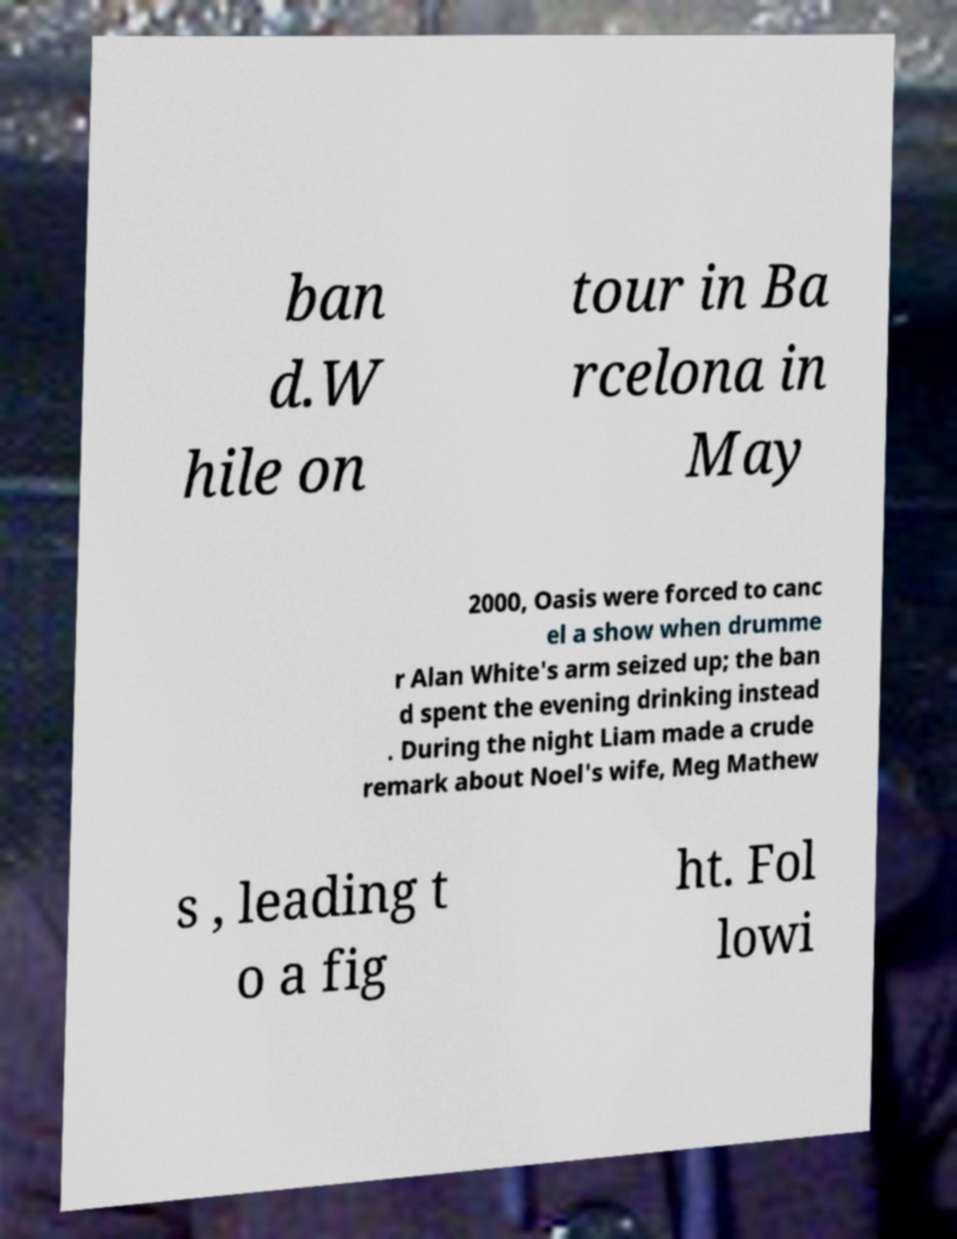Please read and relay the text visible in this image. What does it say? ban d.W hile on tour in Ba rcelona in May 2000, Oasis were forced to canc el a show when drumme r Alan White's arm seized up; the ban d spent the evening drinking instead . During the night Liam made a crude remark about Noel's wife, Meg Mathew s , leading t o a fig ht. Fol lowi 